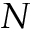<formula> <loc_0><loc_0><loc_500><loc_500>N</formula> 